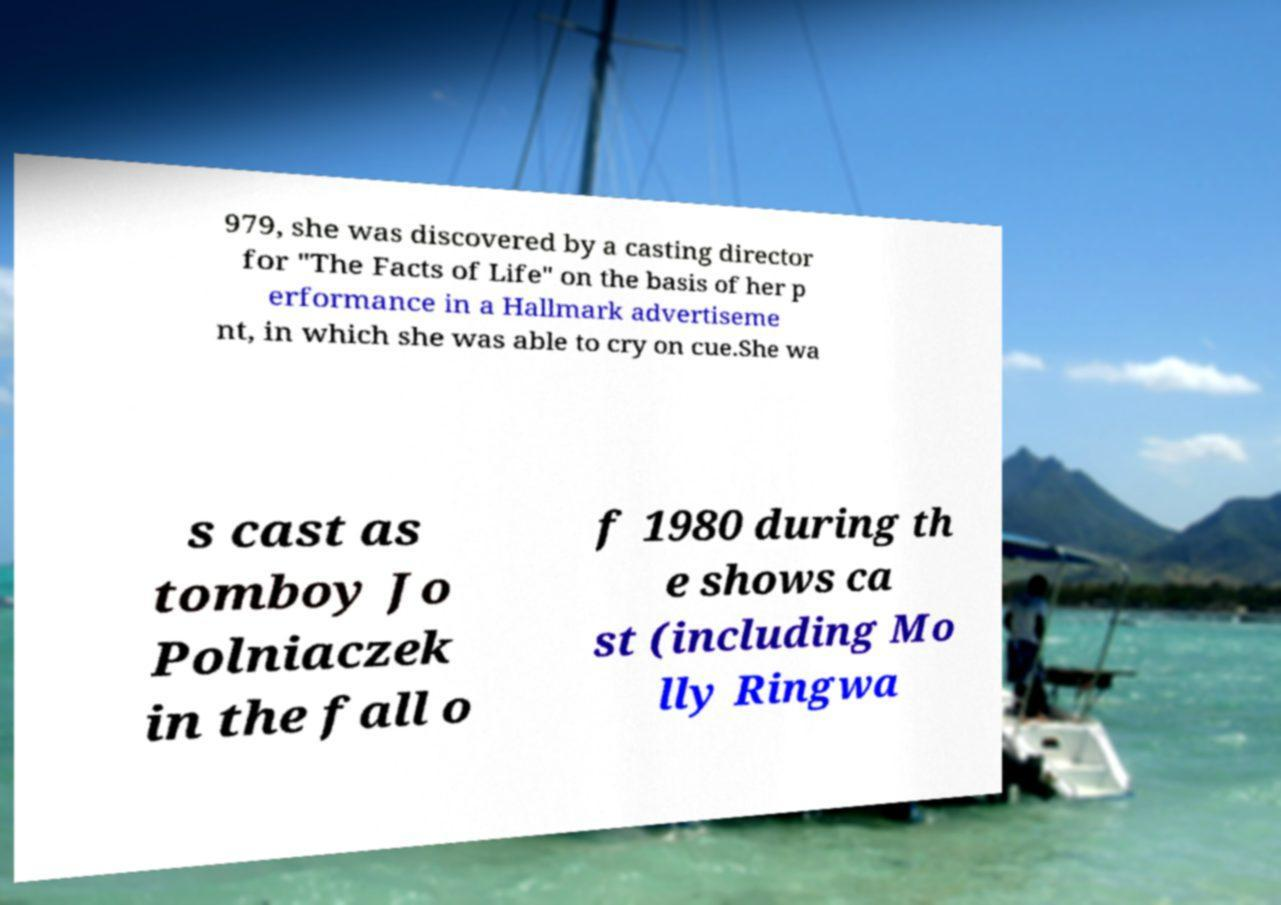Can you accurately transcribe the text from the provided image for me? 979, she was discovered by a casting director for "The Facts of Life" on the basis of her p erformance in a Hallmark advertiseme nt, in which she was able to cry on cue.She wa s cast as tomboy Jo Polniaczek in the fall o f 1980 during th e shows ca st (including Mo lly Ringwa 